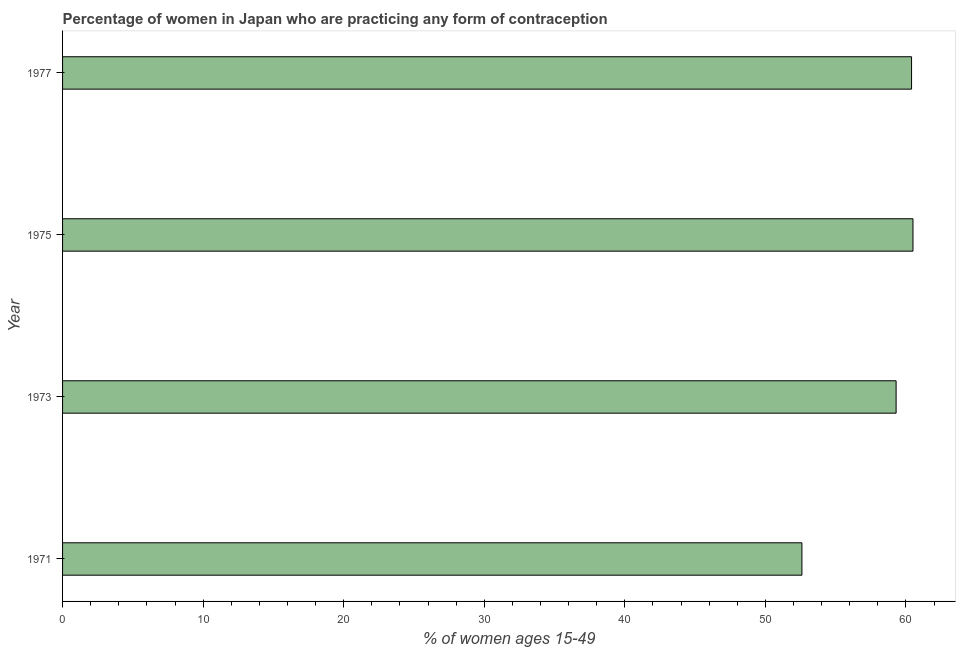Does the graph contain any zero values?
Provide a succinct answer. No. Does the graph contain grids?
Offer a very short reply. No. What is the title of the graph?
Offer a very short reply. Percentage of women in Japan who are practicing any form of contraception. What is the label or title of the X-axis?
Give a very brief answer. % of women ages 15-49. What is the label or title of the Y-axis?
Offer a terse response. Year. What is the contraceptive prevalence in 1975?
Provide a short and direct response. 60.5. Across all years, what is the maximum contraceptive prevalence?
Your answer should be very brief. 60.5. Across all years, what is the minimum contraceptive prevalence?
Your response must be concise. 52.6. In which year was the contraceptive prevalence maximum?
Provide a succinct answer. 1975. In which year was the contraceptive prevalence minimum?
Ensure brevity in your answer.  1971. What is the sum of the contraceptive prevalence?
Your response must be concise. 232.8. What is the difference between the contraceptive prevalence in 1973 and 1975?
Offer a terse response. -1.2. What is the average contraceptive prevalence per year?
Your response must be concise. 58.2. What is the median contraceptive prevalence?
Provide a succinct answer. 59.85. Do a majority of the years between 1977 and 1973 (inclusive) have contraceptive prevalence greater than 48 %?
Keep it short and to the point. Yes. Is the contraceptive prevalence in 1971 less than that in 1977?
Your answer should be very brief. Yes. What is the difference between the highest and the second highest contraceptive prevalence?
Your response must be concise. 0.1. What is the difference between the highest and the lowest contraceptive prevalence?
Provide a short and direct response. 7.9. In how many years, is the contraceptive prevalence greater than the average contraceptive prevalence taken over all years?
Offer a very short reply. 3. How many bars are there?
Provide a short and direct response. 4. How many years are there in the graph?
Make the answer very short. 4. What is the % of women ages 15-49 of 1971?
Make the answer very short. 52.6. What is the % of women ages 15-49 of 1973?
Your response must be concise. 59.3. What is the % of women ages 15-49 of 1975?
Offer a terse response. 60.5. What is the % of women ages 15-49 of 1977?
Provide a short and direct response. 60.4. What is the difference between the % of women ages 15-49 in 1973 and 1977?
Offer a very short reply. -1.1. What is the ratio of the % of women ages 15-49 in 1971 to that in 1973?
Your answer should be very brief. 0.89. What is the ratio of the % of women ages 15-49 in 1971 to that in 1975?
Your answer should be very brief. 0.87. What is the ratio of the % of women ages 15-49 in 1971 to that in 1977?
Your answer should be very brief. 0.87. What is the ratio of the % of women ages 15-49 in 1975 to that in 1977?
Keep it short and to the point. 1. 